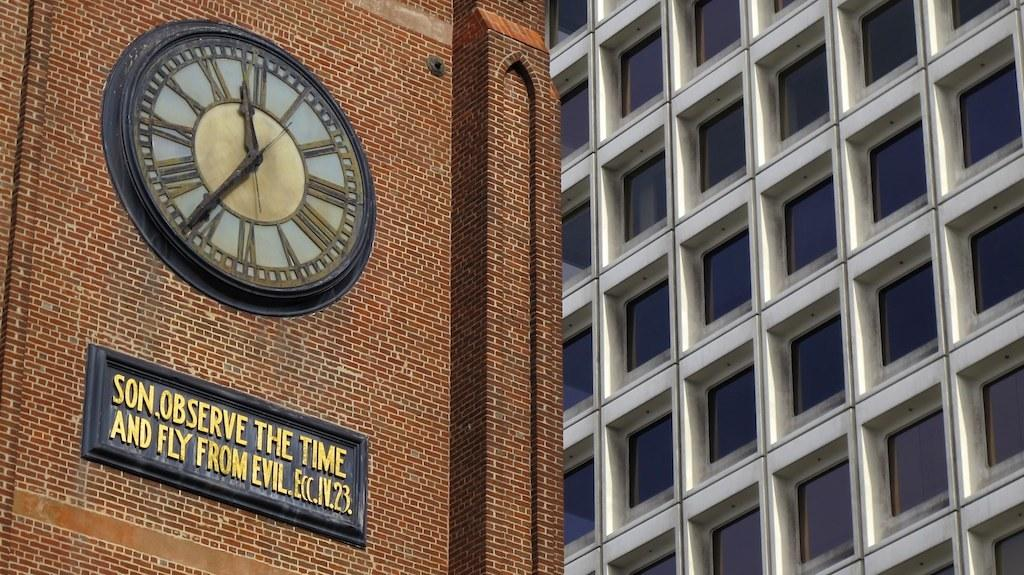<image>
Give a short and clear explanation of the subsequent image. a brick building that has a sign that reads SON, OBSERVE THE TIME AND FLY FROM EVIL 